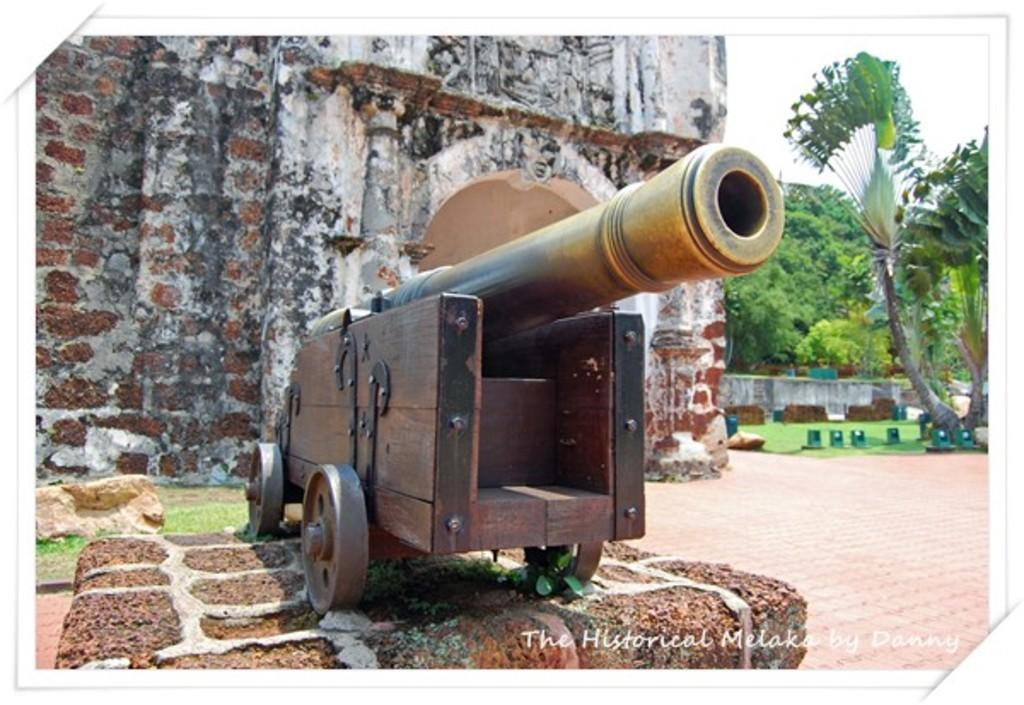What is the main object in the foreground of the image? There is a cannon on a platform in the image. What can be seen in the background of the image? There is a wall, trees, and the sky visible in the background of the image. Are there any other objects or features in the background? Yes, there are unspecified objects in the background of the image. Is there any text present in the image? Yes, there is some text in the bottom right corner of the image. How many toes are visible on the cake in the image? There is no cake or toes present in the image; it features a cannon on a platform with a background that includes a wall, trees, and the sky. What type of lift is used to transport the cannon in the image? There is no lift present in the image; the cannon is on a platform. 